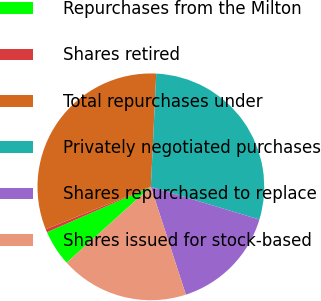<chart> <loc_0><loc_0><loc_500><loc_500><pie_chart><fcel>Repurchases from the Milton<fcel>Shares retired<fcel>Total repurchases under<fcel>Privately negotiated purchases<fcel>Shares repurchased to replace<fcel>Shares issued for stock-based<nl><fcel>5.12%<fcel>0.45%<fcel>31.86%<fcel>28.9%<fcel>15.35%<fcel>18.32%<nl></chart> 